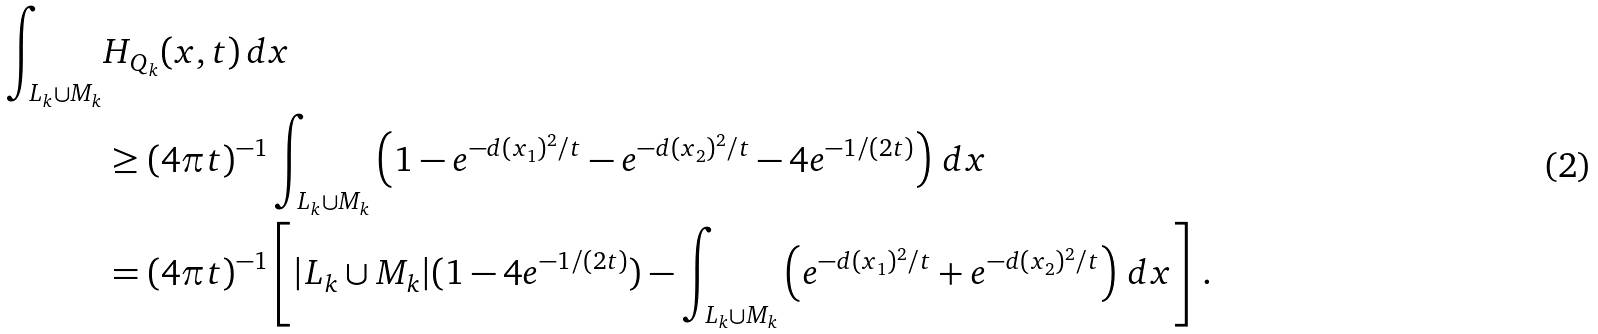<formula> <loc_0><loc_0><loc_500><loc_500>\int _ { L _ { k } \cup M _ { k } } & H _ { Q _ { k } } ( x , t ) \, d x \\ & \geq ( 4 \pi t ) ^ { - 1 } \int _ { L _ { k } \cup M _ { k } } \left ( 1 - e ^ { - d ( x _ { 1 } ) ^ { 2 } / t } - e ^ { - d ( x _ { 2 } ) ^ { 2 } / t } - 4 e ^ { - 1 / ( 2 t ) } \right ) \, d x \\ & = ( 4 \pi t ) ^ { - 1 } \left [ | L _ { k } \cup M _ { k } | ( 1 - 4 e ^ { - 1 / ( 2 t ) } ) - \int _ { L _ { k } \cup M _ { k } } \left ( e ^ { - d ( x _ { 1 } ) ^ { 2 } / t } + e ^ { - d ( x _ { 2 } ) ^ { 2 } / t } \right ) \, d x \right ] \, .</formula> 